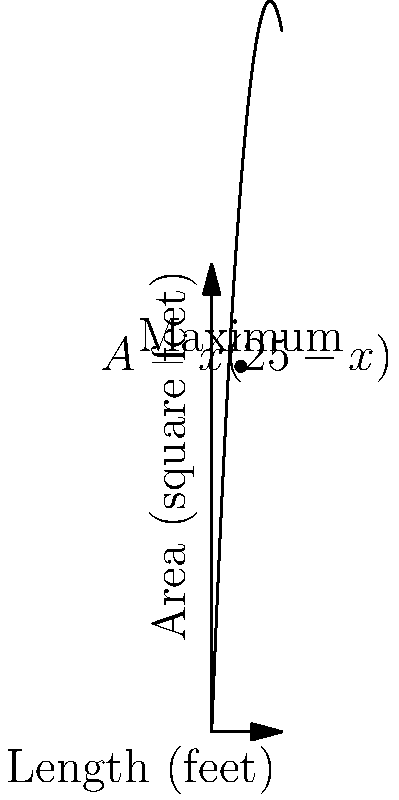Farmer John wants to create a rectangular vegetable garden in his backyard. He has 100 feet of fencing to enclose the garden. What should be the dimensions of the garden to maximize its area? Assume the garden is rectangular with no fencing on one side (against a wall). Let's approach this step-by-step:

1) Let the width of the garden be $x$ feet and the length be $y$ feet.

2) Since there's no fencing on one side, we have:
   $2x + y = 100$ (perimeter equation)

3) We can express $y$ in terms of $x$:
   $y = 100 - 2x$

4) The area $A$ of the garden is:
   $A = xy = x(100 - 2x) = 100x - 2x^2$

5) To find the maximum area, we need to find where the derivative of $A$ with respect to $x$ is zero:
   $\frac{dA}{dx} = 100 - 4x$

6) Set this equal to zero:
   $100 - 4x = 0$
   $4x = 100$
   $x = 25$

7) This critical point gives us the width. To find the length:
   $y = 100 - 2(25) = 50$

8) We can verify this is a maximum by checking the second derivative:
   $\frac{d^2A}{dx^2} = -4$, which is negative, confirming a maximum.

9) Therefore, the dimensions that maximize the area are 25 feet by 50 feet.

10) The maximum area is:
    $A = 25 * 50 = 1250$ square feet
Answer: 25 feet by 50 feet, with a maximum area of 1250 square feet. 